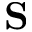Convert formula to latex. <formula><loc_0><loc_0><loc_500><loc_500>{ S }</formula> 